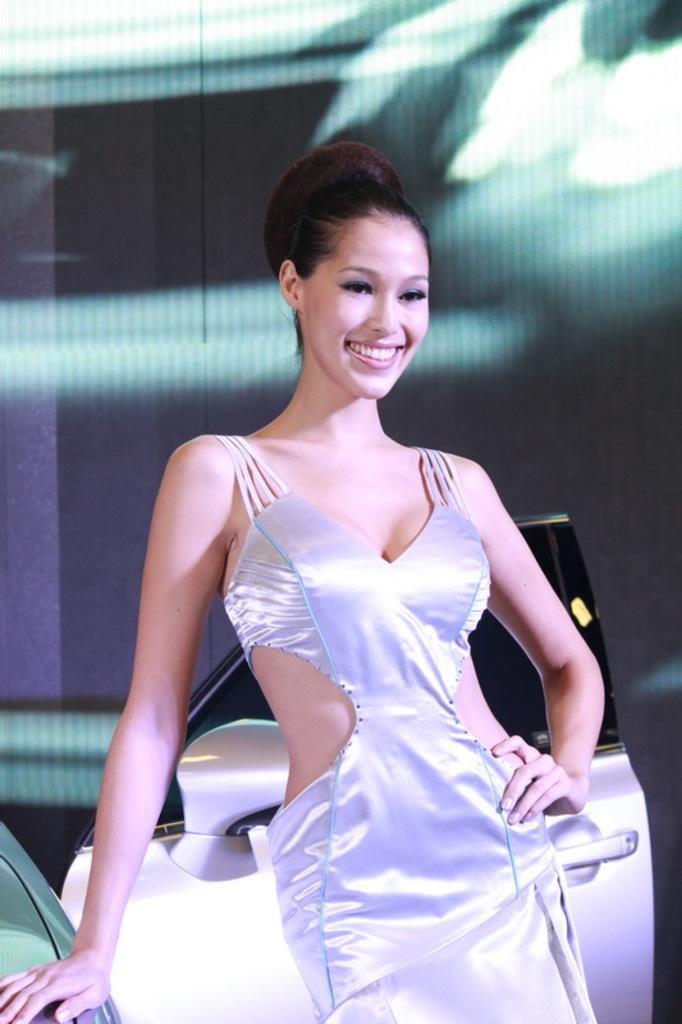Describe this image in one or two sentences. In this picture, there is a woman in the center. Behind her, there is a car. 